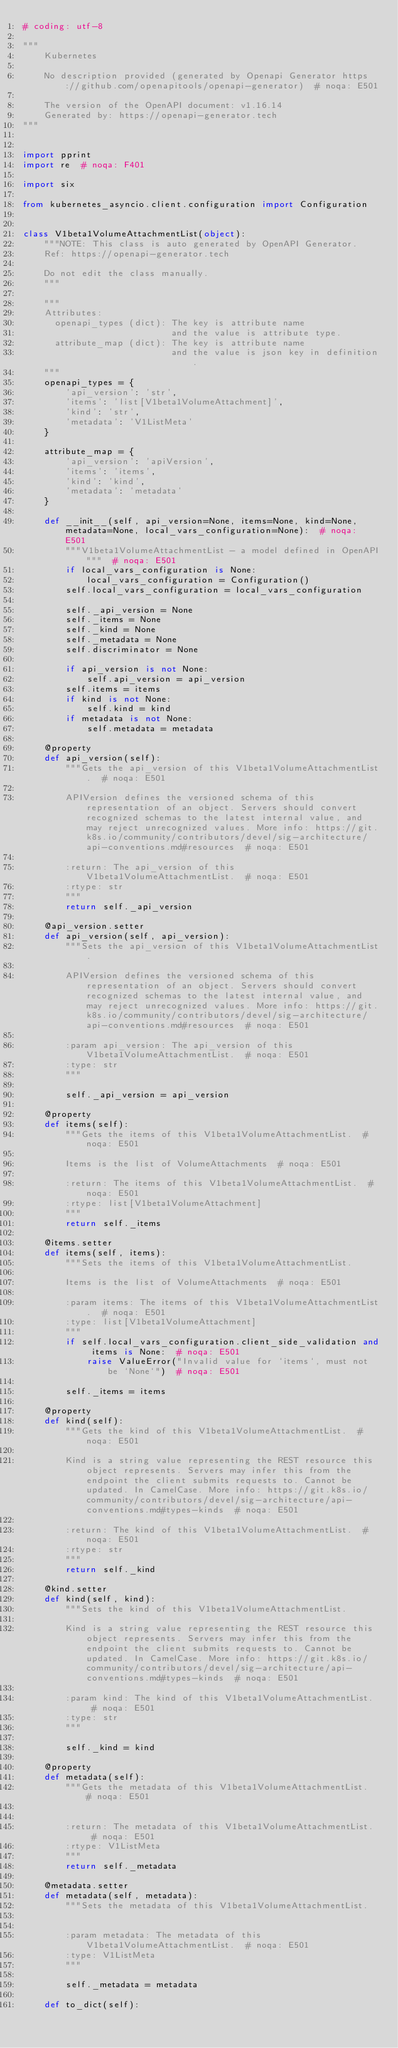Convert code to text. <code><loc_0><loc_0><loc_500><loc_500><_Python_># coding: utf-8

"""
    Kubernetes

    No description provided (generated by Openapi Generator https://github.com/openapitools/openapi-generator)  # noqa: E501

    The version of the OpenAPI document: v1.16.14
    Generated by: https://openapi-generator.tech
"""


import pprint
import re  # noqa: F401

import six

from kubernetes_asyncio.client.configuration import Configuration


class V1beta1VolumeAttachmentList(object):
    """NOTE: This class is auto generated by OpenAPI Generator.
    Ref: https://openapi-generator.tech

    Do not edit the class manually.
    """

    """
    Attributes:
      openapi_types (dict): The key is attribute name
                            and the value is attribute type.
      attribute_map (dict): The key is attribute name
                            and the value is json key in definition.
    """
    openapi_types = {
        'api_version': 'str',
        'items': 'list[V1beta1VolumeAttachment]',
        'kind': 'str',
        'metadata': 'V1ListMeta'
    }

    attribute_map = {
        'api_version': 'apiVersion',
        'items': 'items',
        'kind': 'kind',
        'metadata': 'metadata'
    }

    def __init__(self, api_version=None, items=None, kind=None, metadata=None, local_vars_configuration=None):  # noqa: E501
        """V1beta1VolumeAttachmentList - a model defined in OpenAPI"""  # noqa: E501
        if local_vars_configuration is None:
            local_vars_configuration = Configuration()
        self.local_vars_configuration = local_vars_configuration

        self._api_version = None
        self._items = None
        self._kind = None
        self._metadata = None
        self.discriminator = None

        if api_version is not None:
            self.api_version = api_version
        self.items = items
        if kind is not None:
            self.kind = kind
        if metadata is not None:
            self.metadata = metadata

    @property
    def api_version(self):
        """Gets the api_version of this V1beta1VolumeAttachmentList.  # noqa: E501

        APIVersion defines the versioned schema of this representation of an object. Servers should convert recognized schemas to the latest internal value, and may reject unrecognized values. More info: https://git.k8s.io/community/contributors/devel/sig-architecture/api-conventions.md#resources  # noqa: E501

        :return: The api_version of this V1beta1VolumeAttachmentList.  # noqa: E501
        :rtype: str
        """
        return self._api_version

    @api_version.setter
    def api_version(self, api_version):
        """Sets the api_version of this V1beta1VolumeAttachmentList.

        APIVersion defines the versioned schema of this representation of an object. Servers should convert recognized schemas to the latest internal value, and may reject unrecognized values. More info: https://git.k8s.io/community/contributors/devel/sig-architecture/api-conventions.md#resources  # noqa: E501

        :param api_version: The api_version of this V1beta1VolumeAttachmentList.  # noqa: E501
        :type: str
        """

        self._api_version = api_version

    @property
    def items(self):
        """Gets the items of this V1beta1VolumeAttachmentList.  # noqa: E501

        Items is the list of VolumeAttachments  # noqa: E501

        :return: The items of this V1beta1VolumeAttachmentList.  # noqa: E501
        :rtype: list[V1beta1VolumeAttachment]
        """
        return self._items

    @items.setter
    def items(self, items):
        """Sets the items of this V1beta1VolumeAttachmentList.

        Items is the list of VolumeAttachments  # noqa: E501

        :param items: The items of this V1beta1VolumeAttachmentList.  # noqa: E501
        :type: list[V1beta1VolumeAttachment]
        """
        if self.local_vars_configuration.client_side_validation and items is None:  # noqa: E501
            raise ValueError("Invalid value for `items`, must not be `None`")  # noqa: E501

        self._items = items

    @property
    def kind(self):
        """Gets the kind of this V1beta1VolumeAttachmentList.  # noqa: E501

        Kind is a string value representing the REST resource this object represents. Servers may infer this from the endpoint the client submits requests to. Cannot be updated. In CamelCase. More info: https://git.k8s.io/community/contributors/devel/sig-architecture/api-conventions.md#types-kinds  # noqa: E501

        :return: The kind of this V1beta1VolumeAttachmentList.  # noqa: E501
        :rtype: str
        """
        return self._kind

    @kind.setter
    def kind(self, kind):
        """Sets the kind of this V1beta1VolumeAttachmentList.

        Kind is a string value representing the REST resource this object represents. Servers may infer this from the endpoint the client submits requests to. Cannot be updated. In CamelCase. More info: https://git.k8s.io/community/contributors/devel/sig-architecture/api-conventions.md#types-kinds  # noqa: E501

        :param kind: The kind of this V1beta1VolumeAttachmentList.  # noqa: E501
        :type: str
        """

        self._kind = kind

    @property
    def metadata(self):
        """Gets the metadata of this V1beta1VolumeAttachmentList.  # noqa: E501


        :return: The metadata of this V1beta1VolumeAttachmentList.  # noqa: E501
        :rtype: V1ListMeta
        """
        return self._metadata

    @metadata.setter
    def metadata(self, metadata):
        """Sets the metadata of this V1beta1VolumeAttachmentList.


        :param metadata: The metadata of this V1beta1VolumeAttachmentList.  # noqa: E501
        :type: V1ListMeta
        """

        self._metadata = metadata

    def to_dict(self):</code> 